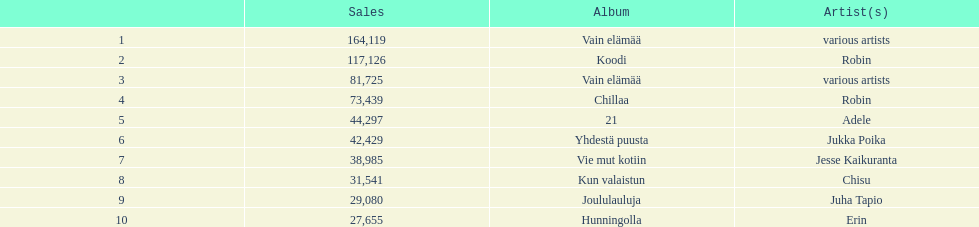Give me the full table as a dictionary. {'header': ['', 'Sales', 'Album', 'Artist(s)'], 'rows': [['1', '164,119', 'Vain elämää', 'various artists'], ['2', '117,126', 'Koodi', 'Robin'], ['3', '81,725', 'Vain elämää', 'various artists'], ['4', '73,439', 'Chillaa', 'Robin'], ['5', '44,297', '21', 'Adele'], ['6', '42,429', 'Yhdestä puusta', 'Jukka Poika'], ['7', '38,985', 'Vie mut kotiin', 'Jesse Kaikuranta'], ['8', '31,541', 'Kun valaistun', 'Chisu'], ['9', '29,080', 'Joululauluja', 'Juha Tapio'], ['10', '27,655', 'Hunningolla', 'Erin']]} Which was better selling, hunningolla or vain elamaa? Vain elämää. 